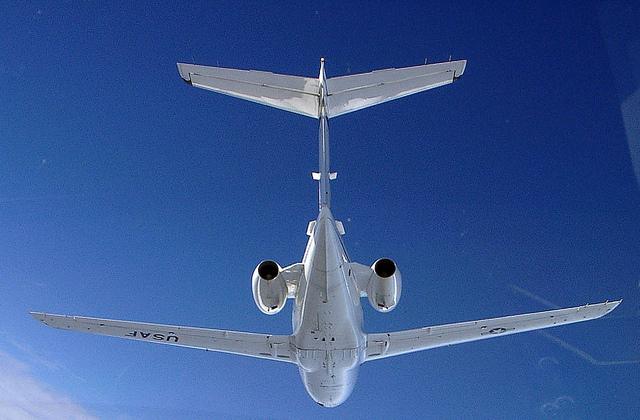Is there bad weather?
Keep it brief. No. What is written on the underside of the wing on the left?
Quick response, please. Usaf. Is this plane in the air?
Be succinct. Yes. 